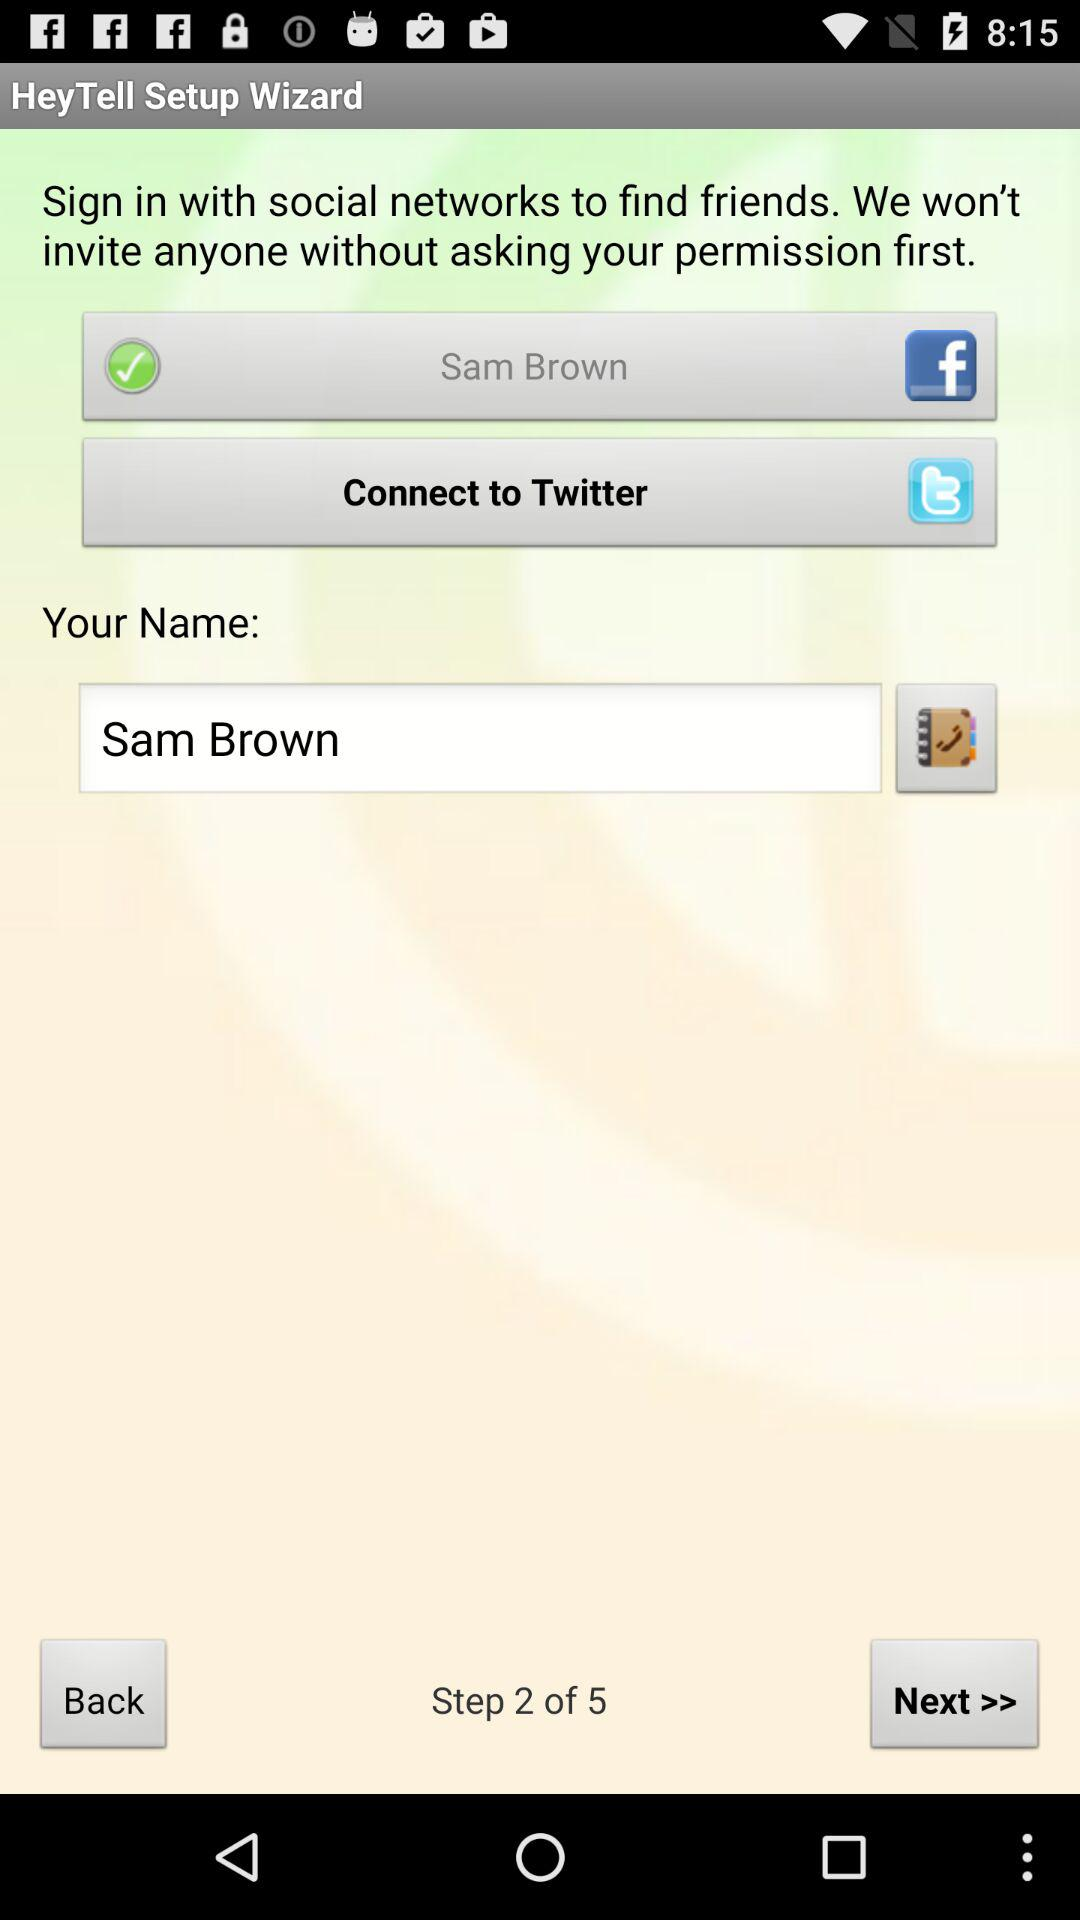What is the name? The name is Sam Brown. 